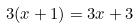Convert formula to latex. <formula><loc_0><loc_0><loc_500><loc_500>3 ( x + 1 ) = 3 x + 3</formula> 